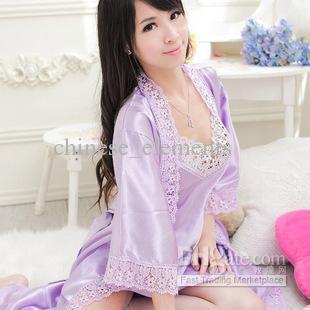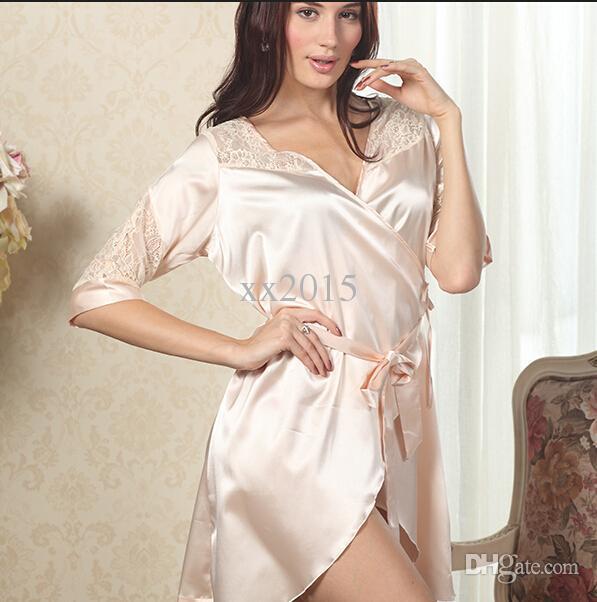The first image is the image on the left, the second image is the image on the right. Considering the images on both sides, is "There is a woman facing right in the left image." valid? Answer yes or no. Yes. 